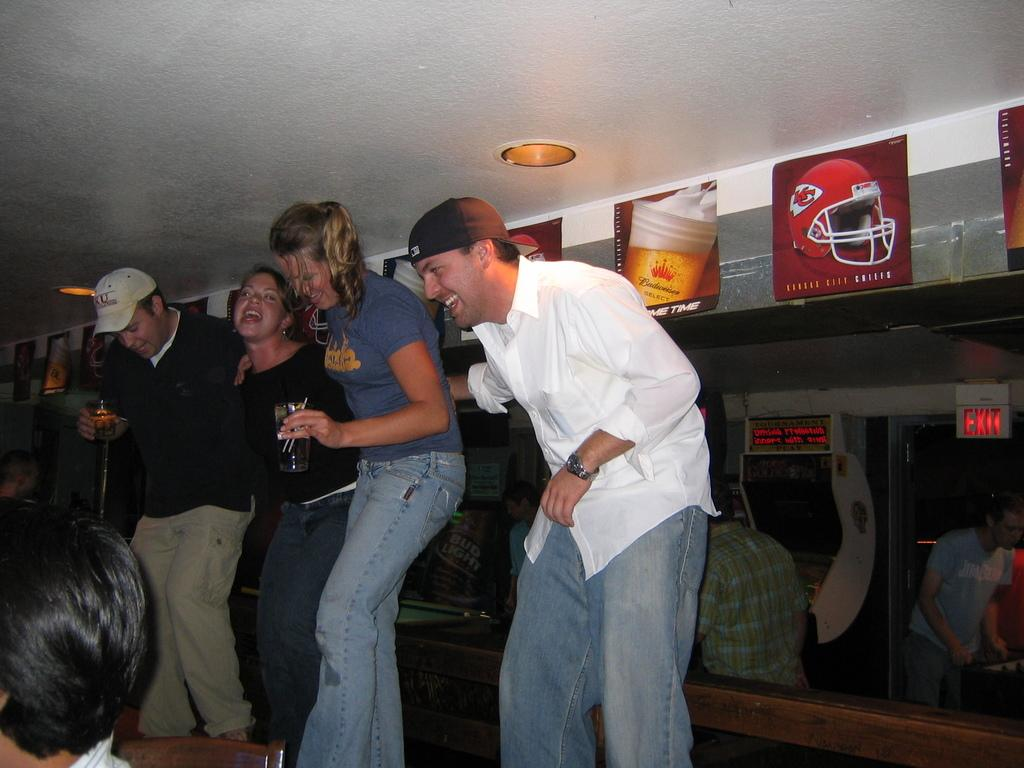What type of structure can be seen in the image? There is a wall in the image. What architectural feature is present in the wall? There are windows in the image. Who or what is present in the image? There is a group of people in the image. What is the source of light in the image? There is light visible in the image. What type of decorations are present in the image? There are posters in the image. What type of wood can be seen being used as a hand in the image? There is no wood or hand present in the image. What question is being asked by the person in the image? There is no person asking a question in the image. 